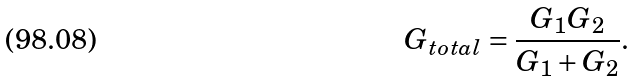<formula> <loc_0><loc_0><loc_500><loc_500>G _ { t o t a l } = { \frac { G _ { 1 } G _ { 2 } } { G _ { 1 } + G _ { 2 } } } .</formula> 